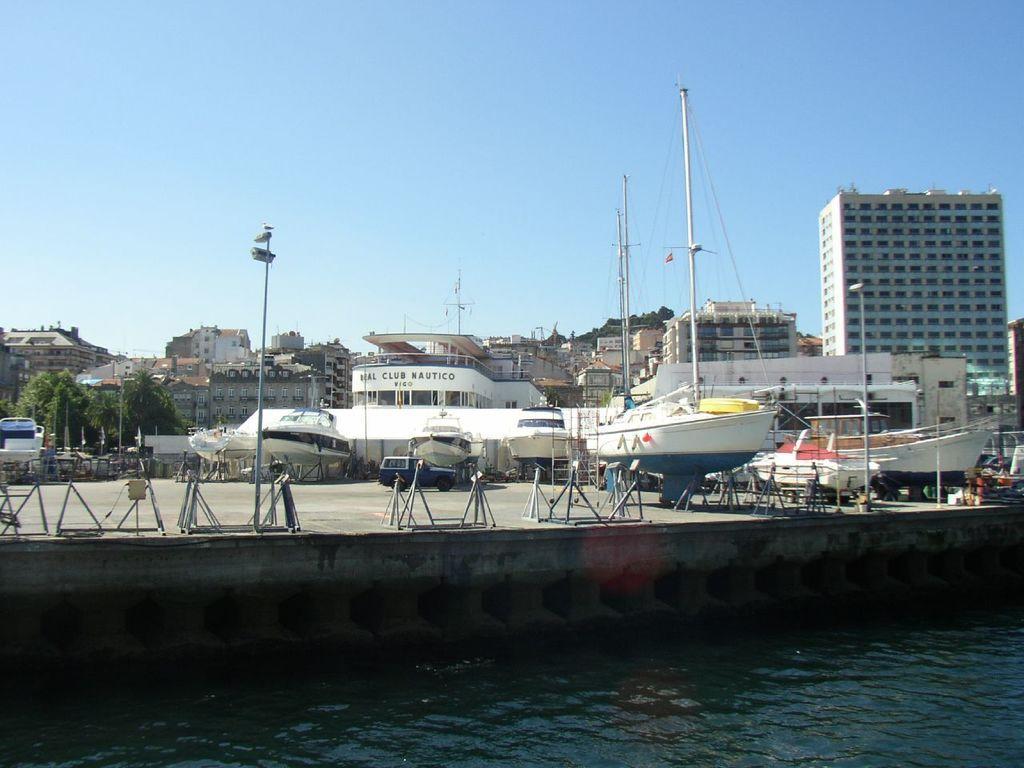Can you describe this image briefly? In this image I can see at the bottom there is the water, in the middle there are boats, at the back side there are trees and buildings. At the top it is the sky. 